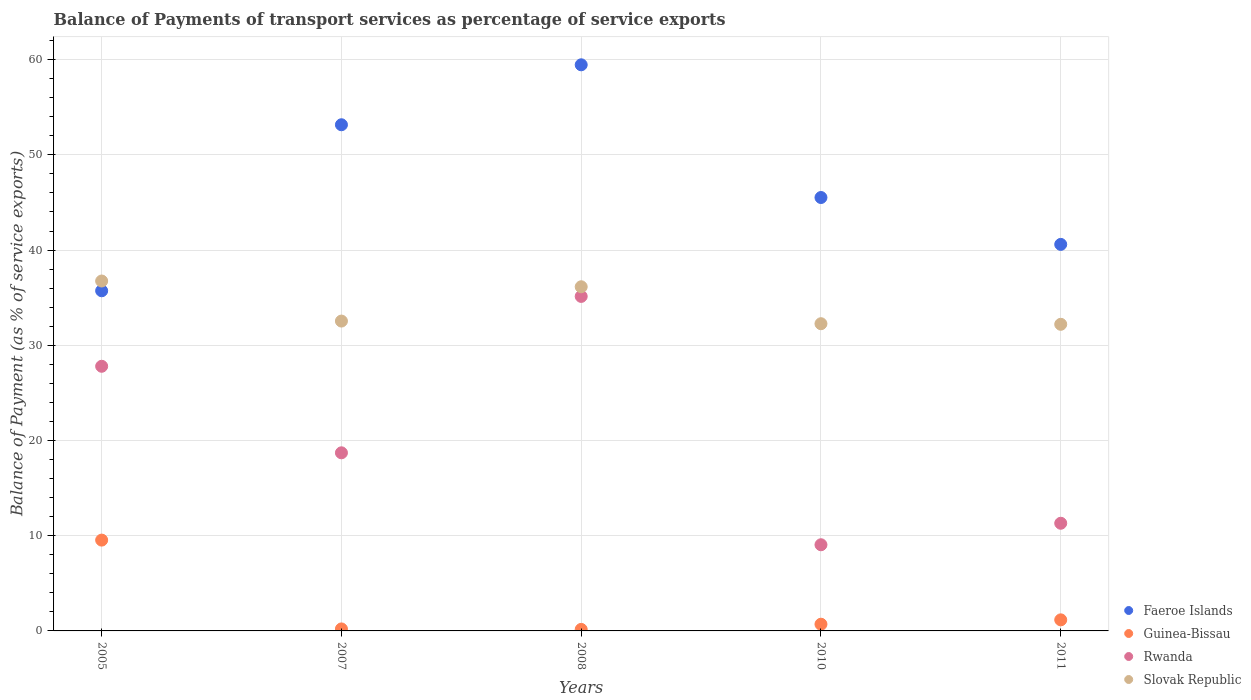Is the number of dotlines equal to the number of legend labels?
Offer a terse response. Yes. What is the balance of payments of transport services in Rwanda in 2007?
Provide a succinct answer. 18.71. Across all years, what is the maximum balance of payments of transport services in Guinea-Bissau?
Offer a terse response. 9.54. Across all years, what is the minimum balance of payments of transport services in Slovak Republic?
Give a very brief answer. 32.2. In which year was the balance of payments of transport services in Slovak Republic maximum?
Make the answer very short. 2005. What is the total balance of payments of transport services in Guinea-Bissau in the graph?
Your answer should be compact. 11.77. What is the difference between the balance of payments of transport services in Slovak Republic in 2007 and that in 2008?
Ensure brevity in your answer.  -3.6. What is the difference between the balance of payments of transport services in Rwanda in 2005 and the balance of payments of transport services in Guinea-Bissau in 2007?
Provide a short and direct response. 27.58. What is the average balance of payments of transport services in Slovak Republic per year?
Ensure brevity in your answer.  33.98. In the year 2010, what is the difference between the balance of payments of transport services in Guinea-Bissau and balance of payments of transport services in Rwanda?
Your response must be concise. -8.34. In how many years, is the balance of payments of transport services in Faeroe Islands greater than 44 %?
Keep it short and to the point. 3. What is the ratio of the balance of payments of transport services in Slovak Republic in 2007 to that in 2008?
Offer a terse response. 0.9. What is the difference between the highest and the second highest balance of payments of transport services in Slovak Republic?
Ensure brevity in your answer.  0.6. What is the difference between the highest and the lowest balance of payments of transport services in Rwanda?
Offer a very short reply. 26.08. In how many years, is the balance of payments of transport services in Rwanda greater than the average balance of payments of transport services in Rwanda taken over all years?
Keep it short and to the point. 2. Is the sum of the balance of payments of transport services in Faeroe Islands in 2010 and 2011 greater than the maximum balance of payments of transport services in Rwanda across all years?
Make the answer very short. Yes. Is it the case that in every year, the sum of the balance of payments of transport services in Guinea-Bissau and balance of payments of transport services in Slovak Republic  is greater than the sum of balance of payments of transport services in Faeroe Islands and balance of payments of transport services in Rwanda?
Give a very brief answer. No. Is it the case that in every year, the sum of the balance of payments of transport services in Slovak Republic and balance of payments of transport services in Rwanda  is greater than the balance of payments of transport services in Guinea-Bissau?
Your answer should be compact. Yes. Is the balance of payments of transport services in Rwanda strictly greater than the balance of payments of transport services in Faeroe Islands over the years?
Make the answer very short. No. How many dotlines are there?
Keep it short and to the point. 4. What is the difference between two consecutive major ticks on the Y-axis?
Provide a succinct answer. 10. Does the graph contain any zero values?
Ensure brevity in your answer.  No. Where does the legend appear in the graph?
Your answer should be compact. Bottom right. How are the legend labels stacked?
Provide a succinct answer. Vertical. What is the title of the graph?
Offer a very short reply. Balance of Payments of transport services as percentage of service exports. Does "Solomon Islands" appear as one of the legend labels in the graph?
Ensure brevity in your answer.  No. What is the label or title of the Y-axis?
Your response must be concise. Balance of Payment (as % of service exports). What is the Balance of Payment (as % of service exports) of Faeroe Islands in 2005?
Ensure brevity in your answer.  35.72. What is the Balance of Payment (as % of service exports) of Guinea-Bissau in 2005?
Your answer should be very brief. 9.54. What is the Balance of Payment (as % of service exports) of Rwanda in 2005?
Your answer should be very brief. 27.79. What is the Balance of Payment (as % of service exports) in Slovak Republic in 2005?
Offer a terse response. 36.75. What is the Balance of Payment (as % of service exports) in Faeroe Islands in 2007?
Provide a short and direct response. 53.16. What is the Balance of Payment (as % of service exports) of Guinea-Bissau in 2007?
Your answer should be compact. 0.21. What is the Balance of Payment (as % of service exports) of Rwanda in 2007?
Provide a succinct answer. 18.71. What is the Balance of Payment (as % of service exports) of Slovak Republic in 2007?
Your response must be concise. 32.54. What is the Balance of Payment (as % of service exports) of Faeroe Islands in 2008?
Your answer should be compact. 59.46. What is the Balance of Payment (as % of service exports) of Guinea-Bissau in 2008?
Your answer should be compact. 0.16. What is the Balance of Payment (as % of service exports) in Rwanda in 2008?
Your response must be concise. 35.13. What is the Balance of Payment (as % of service exports) of Slovak Republic in 2008?
Your answer should be compact. 36.14. What is the Balance of Payment (as % of service exports) of Faeroe Islands in 2010?
Make the answer very short. 45.52. What is the Balance of Payment (as % of service exports) in Guinea-Bissau in 2010?
Provide a succinct answer. 0.7. What is the Balance of Payment (as % of service exports) of Rwanda in 2010?
Provide a short and direct response. 9.05. What is the Balance of Payment (as % of service exports) in Slovak Republic in 2010?
Offer a very short reply. 32.27. What is the Balance of Payment (as % of service exports) of Faeroe Islands in 2011?
Your answer should be very brief. 40.59. What is the Balance of Payment (as % of service exports) in Guinea-Bissau in 2011?
Your answer should be compact. 1.16. What is the Balance of Payment (as % of service exports) in Rwanda in 2011?
Your answer should be very brief. 11.31. What is the Balance of Payment (as % of service exports) of Slovak Republic in 2011?
Keep it short and to the point. 32.2. Across all years, what is the maximum Balance of Payment (as % of service exports) of Faeroe Islands?
Your response must be concise. 59.46. Across all years, what is the maximum Balance of Payment (as % of service exports) in Guinea-Bissau?
Provide a succinct answer. 9.54. Across all years, what is the maximum Balance of Payment (as % of service exports) in Rwanda?
Your response must be concise. 35.13. Across all years, what is the maximum Balance of Payment (as % of service exports) in Slovak Republic?
Provide a short and direct response. 36.75. Across all years, what is the minimum Balance of Payment (as % of service exports) of Faeroe Islands?
Provide a succinct answer. 35.72. Across all years, what is the minimum Balance of Payment (as % of service exports) of Guinea-Bissau?
Provide a short and direct response. 0.16. Across all years, what is the minimum Balance of Payment (as % of service exports) in Rwanda?
Provide a short and direct response. 9.05. Across all years, what is the minimum Balance of Payment (as % of service exports) in Slovak Republic?
Make the answer very short. 32.2. What is the total Balance of Payment (as % of service exports) of Faeroe Islands in the graph?
Give a very brief answer. 234.45. What is the total Balance of Payment (as % of service exports) in Guinea-Bissau in the graph?
Make the answer very short. 11.77. What is the total Balance of Payment (as % of service exports) in Rwanda in the graph?
Your answer should be very brief. 101.99. What is the total Balance of Payment (as % of service exports) of Slovak Republic in the graph?
Ensure brevity in your answer.  169.9. What is the difference between the Balance of Payment (as % of service exports) in Faeroe Islands in 2005 and that in 2007?
Your answer should be compact. -17.44. What is the difference between the Balance of Payment (as % of service exports) of Guinea-Bissau in 2005 and that in 2007?
Offer a very short reply. 9.33. What is the difference between the Balance of Payment (as % of service exports) of Rwanda in 2005 and that in 2007?
Keep it short and to the point. 9.09. What is the difference between the Balance of Payment (as % of service exports) of Slovak Republic in 2005 and that in 2007?
Provide a short and direct response. 4.21. What is the difference between the Balance of Payment (as % of service exports) of Faeroe Islands in 2005 and that in 2008?
Provide a short and direct response. -23.73. What is the difference between the Balance of Payment (as % of service exports) of Guinea-Bissau in 2005 and that in 2008?
Keep it short and to the point. 9.38. What is the difference between the Balance of Payment (as % of service exports) in Rwanda in 2005 and that in 2008?
Make the answer very short. -7.34. What is the difference between the Balance of Payment (as % of service exports) in Slovak Republic in 2005 and that in 2008?
Provide a succinct answer. 0.6. What is the difference between the Balance of Payment (as % of service exports) of Faeroe Islands in 2005 and that in 2010?
Your answer should be compact. -9.8. What is the difference between the Balance of Payment (as % of service exports) in Guinea-Bissau in 2005 and that in 2010?
Give a very brief answer. 8.83. What is the difference between the Balance of Payment (as % of service exports) in Rwanda in 2005 and that in 2010?
Provide a short and direct response. 18.74. What is the difference between the Balance of Payment (as % of service exports) in Slovak Republic in 2005 and that in 2010?
Your answer should be very brief. 4.48. What is the difference between the Balance of Payment (as % of service exports) of Faeroe Islands in 2005 and that in 2011?
Make the answer very short. -4.87. What is the difference between the Balance of Payment (as % of service exports) of Guinea-Bissau in 2005 and that in 2011?
Provide a short and direct response. 8.37. What is the difference between the Balance of Payment (as % of service exports) of Rwanda in 2005 and that in 2011?
Provide a succinct answer. 16.49. What is the difference between the Balance of Payment (as % of service exports) in Slovak Republic in 2005 and that in 2011?
Offer a terse response. 4.55. What is the difference between the Balance of Payment (as % of service exports) in Faeroe Islands in 2007 and that in 2008?
Offer a terse response. -6.3. What is the difference between the Balance of Payment (as % of service exports) of Guinea-Bissau in 2007 and that in 2008?
Provide a succinct answer. 0.05. What is the difference between the Balance of Payment (as % of service exports) of Rwanda in 2007 and that in 2008?
Provide a short and direct response. -16.43. What is the difference between the Balance of Payment (as % of service exports) in Slovak Republic in 2007 and that in 2008?
Your answer should be very brief. -3.6. What is the difference between the Balance of Payment (as % of service exports) in Faeroe Islands in 2007 and that in 2010?
Make the answer very short. 7.64. What is the difference between the Balance of Payment (as % of service exports) in Guinea-Bissau in 2007 and that in 2010?
Provide a short and direct response. -0.5. What is the difference between the Balance of Payment (as % of service exports) of Rwanda in 2007 and that in 2010?
Ensure brevity in your answer.  9.66. What is the difference between the Balance of Payment (as % of service exports) of Slovak Republic in 2007 and that in 2010?
Give a very brief answer. 0.28. What is the difference between the Balance of Payment (as % of service exports) in Faeroe Islands in 2007 and that in 2011?
Your response must be concise. 12.57. What is the difference between the Balance of Payment (as % of service exports) in Guinea-Bissau in 2007 and that in 2011?
Offer a terse response. -0.95. What is the difference between the Balance of Payment (as % of service exports) of Rwanda in 2007 and that in 2011?
Make the answer very short. 7.4. What is the difference between the Balance of Payment (as % of service exports) of Slovak Republic in 2007 and that in 2011?
Make the answer very short. 0.34. What is the difference between the Balance of Payment (as % of service exports) in Faeroe Islands in 2008 and that in 2010?
Provide a succinct answer. 13.94. What is the difference between the Balance of Payment (as % of service exports) in Guinea-Bissau in 2008 and that in 2010?
Give a very brief answer. -0.54. What is the difference between the Balance of Payment (as % of service exports) of Rwanda in 2008 and that in 2010?
Your answer should be compact. 26.08. What is the difference between the Balance of Payment (as % of service exports) of Slovak Republic in 2008 and that in 2010?
Make the answer very short. 3.88. What is the difference between the Balance of Payment (as % of service exports) in Faeroe Islands in 2008 and that in 2011?
Offer a terse response. 18.86. What is the difference between the Balance of Payment (as % of service exports) in Guinea-Bissau in 2008 and that in 2011?
Make the answer very short. -1. What is the difference between the Balance of Payment (as % of service exports) in Rwanda in 2008 and that in 2011?
Make the answer very short. 23.82. What is the difference between the Balance of Payment (as % of service exports) of Slovak Republic in 2008 and that in 2011?
Give a very brief answer. 3.94. What is the difference between the Balance of Payment (as % of service exports) of Faeroe Islands in 2010 and that in 2011?
Make the answer very short. 4.92. What is the difference between the Balance of Payment (as % of service exports) of Guinea-Bissau in 2010 and that in 2011?
Give a very brief answer. -0.46. What is the difference between the Balance of Payment (as % of service exports) of Rwanda in 2010 and that in 2011?
Offer a terse response. -2.26. What is the difference between the Balance of Payment (as % of service exports) of Slovak Republic in 2010 and that in 2011?
Provide a succinct answer. 0.06. What is the difference between the Balance of Payment (as % of service exports) of Faeroe Islands in 2005 and the Balance of Payment (as % of service exports) of Guinea-Bissau in 2007?
Keep it short and to the point. 35.51. What is the difference between the Balance of Payment (as % of service exports) of Faeroe Islands in 2005 and the Balance of Payment (as % of service exports) of Rwanda in 2007?
Make the answer very short. 17.02. What is the difference between the Balance of Payment (as % of service exports) in Faeroe Islands in 2005 and the Balance of Payment (as % of service exports) in Slovak Republic in 2007?
Make the answer very short. 3.18. What is the difference between the Balance of Payment (as % of service exports) in Guinea-Bissau in 2005 and the Balance of Payment (as % of service exports) in Rwanda in 2007?
Provide a succinct answer. -9.17. What is the difference between the Balance of Payment (as % of service exports) in Guinea-Bissau in 2005 and the Balance of Payment (as % of service exports) in Slovak Republic in 2007?
Provide a succinct answer. -23. What is the difference between the Balance of Payment (as % of service exports) in Rwanda in 2005 and the Balance of Payment (as % of service exports) in Slovak Republic in 2007?
Provide a succinct answer. -4.75. What is the difference between the Balance of Payment (as % of service exports) in Faeroe Islands in 2005 and the Balance of Payment (as % of service exports) in Guinea-Bissau in 2008?
Give a very brief answer. 35.56. What is the difference between the Balance of Payment (as % of service exports) of Faeroe Islands in 2005 and the Balance of Payment (as % of service exports) of Rwanda in 2008?
Your response must be concise. 0.59. What is the difference between the Balance of Payment (as % of service exports) of Faeroe Islands in 2005 and the Balance of Payment (as % of service exports) of Slovak Republic in 2008?
Provide a short and direct response. -0.42. What is the difference between the Balance of Payment (as % of service exports) of Guinea-Bissau in 2005 and the Balance of Payment (as % of service exports) of Rwanda in 2008?
Provide a short and direct response. -25.59. What is the difference between the Balance of Payment (as % of service exports) of Guinea-Bissau in 2005 and the Balance of Payment (as % of service exports) of Slovak Republic in 2008?
Your response must be concise. -26.61. What is the difference between the Balance of Payment (as % of service exports) in Rwanda in 2005 and the Balance of Payment (as % of service exports) in Slovak Republic in 2008?
Keep it short and to the point. -8.35. What is the difference between the Balance of Payment (as % of service exports) of Faeroe Islands in 2005 and the Balance of Payment (as % of service exports) of Guinea-Bissau in 2010?
Provide a short and direct response. 35.02. What is the difference between the Balance of Payment (as % of service exports) in Faeroe Islands in 2005 and the Balance of Payment (as % of service exports) in Rwanda in 2010?
Offer a terse response. 26.67. What is the difference between the Balance of Payment (as % of service exports) of Faeroe Islands in 2005 and the Balance of Payment (as % of service exports) of Slovak Republic in 2010?
Your response must be concise. 3.46. What is the difference between the Balance of Payment (as % of service exports) in Guinea-Bissau in 2005 and the Balance of Payment (as % of service exports) in Rwanda in 2010?
Your answer should be compact. 0.49. What is the difference between the Balance of Payment (as % of service exports) in Guinea-Bissau in 2005 and the Balance of Payment (as % of service exports) in Slovak Republic in 2010?
Provide a short and direct response. -22.73. What is the difference between the Balance of Payment (as % of service exports) in Rwanda in 2005 and the Balance of Payment (as % of service exports) in Slovak Republic in 2010?
Provide a succinct answer. -4.47. What is the difference between the Balance of Payment (as % of service exports) in Faeroe Islands in 2005 and the Balance of Payment (as % of service exports) in Guinea-Bissau in 2011?
Ensure brevity in your answer.  34.56. What is the difference between the Balance of Payment (as % of service exports) in Faeroe Islands in 2005 and the Balance of Payment (as % of service exports) in Rwanda in 2011?
Make the answer very short. 24.42. What is the difference between the Balance of Payment (as % of service exports) of Faeroe Islands in 2005 and the Balance of Payment (as % of service exports) of Slovak Republic in 2011?
Your answer should be compact. 3.52. What is the difference between the Balance of Payment (as % of service exports) of Guinea-Bissau in 2005 and the Balance of Payment (as % of service exports) of Rwanda in 2011?
Your response must be concise. -1.77. What is the difference between the Balance of Payment (as % of service exports) in Guinea-Bissau in 2005 and the Balance of Payment (as % of service exports) in Slovak Republic in 2011?
Offer a terse response. -22.67. What is the difference between the Balance of Payment (as % of service exports) of Rwanda in 2005 and the Balance of Payment (as % of service exports) of Slovak Republic in 2011?
Give a very brief answer. -4.41. What is the difference between the Balance of Payment (as % of service exports) in Faeroe Islands in 2007 and the Balance of Payment (as % of service exports) in Guinea-Bissau in 2008?
Keep it short and to the point. 53. What is the difference between the Balance of Payment (as % of service exports) of Faeroe Islands in 2007 and the Balance of Payment (as % of service exports) of Rwanda in 2008?
Your answer should be compact. 18.03. What is the difference between the Balance of Payment (as % of service exports) of Faeroe Islands in 2007 and the Balance of Payment (as % of service exports) of Slovak Republic in 2008?
Provide a succinct answer. 17.02. What is the difference between the Balance of Payment (as % of service exports) in Guinea-Bissau in 2007 and the Balance of Payment (as % of service exports) in Rwanda in 2008?
Provide a succinct answer. -34.92. What is the difference between the Balance of Payment (as % of service exports) of Guinea-Bissau in 2007 and the Balance of Payment (as % of service exports) of Slovak Republic in 2008?
Ensure brevity in your answer.  -35.94. What is the difference between the Balance of Payment (as % of service exports) in Rwanda in 2007 and the Balance of Payment (as % of service exports) in Slovak Republic in 2008?
Keep it short and to the point. -17.44. What is the difference between the Balance of Payment (as % of service exports) in Faeroe Islands in 2007 and the Balance of Payment (as % of service exports) in Guinea-Bissau in 2010?
Ensure brevity in your answer.  52.46. What is the difference between the Balance of Payment (as % of service exports) of Faeroe Islands in 2007 and the Balance of Payment (as % of service exports) of Rwanda in 2010?
Give a very brief answer. 44.11. What is the difference between the Balance of Payment (as % of service exports) of Faeroe Islands in 2007 and the Balance of Payment (as % of service exports) of Slovak Republic in 2010?
Make the answer very short. 20.89. What is the difference between the Balance of Payment (as % of service exports) in Guinea-Bissau in 2007 and the Balance of Payment (as % of service exports) in Rwanda in 2010?
Provide a succinct answer. -8.84. What is the difference between the Balance of Payment (as % of service exports) of Guinea-Bissau in 2007 and the Balance of Payment (as % of service exports) of Slovak Republic in 2010?
Your answer should be compact. -32.06. What is the difference between the Balance of Payment (as % of service exports) in Rwanda in 2007 and the Balance of Payment (as % of service exports) in Slovak Republic in 2010?
Provide a succinct answer. -13.56. What is the difference between the Balance of Payment (as % of service exports) in Faeroe Islands in 2007 and the Balance of Payment (as % of service exports) in Guinea-Bissau in 2011?
Provide a short and direct response. 52. What is the difference between the Balance of Payment (as % of service exports) in Faeroe Islands in 2007 and the Balance of Payment (as % of service exports) in Rwanda in 2011?
Provide a succinct answer. 41.85. What is the difference between the Balance of Payment (as % of service exports) in Faeroe Islands in 2007 and the Balance of Payment (as % of service exports) in Slovak Republic in 2011?
Provide a short and direct response. 20.96. What is the difference between the Balance of Payment (as % of service exports) of Guinea-Bissau in 2007 and the Balance of Payment (as % of service exports) of Rwanda in 2011?
Your response must be concise. -11.1. What is the difference between the Balance of Payment (as % of service exports) of Guinea-Bissau in 2007 and the Balance of Payment (as % of service exports) of Slovak Republic in 2011?
Your answer should be very brief. -31.99. What is the difference between the Balance of Payment (as % of service exports) of Rwanda in 2007 and the Balance of Payment (as % of service exports) of Slovak Republic in 2011?
Keep it short and to the point. -13.5. What is the difference between the Balance of Payment (as % of service exports) of Faeroe Islands in 2008 and the Balance of Payment (as % of service exports) of Guinea-Bissau in 2010?
Offer a very short reply. 58.75. What is the difference between the Balance of Payment (as % of service exports) of Faeroe Islands in 2008 and the Balance of Payment (as % of service exports) of Rwanda in 2010?
Offer a very short reply. 50.41. What is the difference between the Balance of Payment (as % of service exports) in Faeroe Islands in 2008 and the Balance of Payment (as % of service exports) in Slovak Republic in 2010?
Provide a succinct answer. 27.19. What is the difference between the Balance of Payment (as % of service exports) in Guinea-Bissau in 2008 and the Balance of Payment (as % of service exports) in Rwanda in 2010?
Give a very brief answer. -8.89. What is the difference between the Balance of Payment (as % of service exports) of Guinea-Bissau in 2008 and the Balance of Payment (as % of service exports) of Slovak Republic in 2010?
Ensure brevity in your answer.  -32.11. What is the difference between the Balance of Payment (as % of service exports) of Rwanda in 2008 and the Balance of Payment (as % of service exports) of Slovak Republic in 2010?
Offer a terse response. 2.87. What is the difference between the Balance of Payment (as % of service exports) of Faeroe Islands in 2008 and the Balance of Payment (as % of service exports) of Guinea-Bissau in 2011?
Provide a succinct answer. 58.29. What is the difference between the Balance of Payment (as % of service exports) in Faeroe Islands in 2008 and the Balance of Payment (as % of service exports) in Rwanda in 2011?
Your answer should be very brief. 48.15. What is the difference between the Balance of Payment (as % of service exports) of Faeroe Islands in 2008 and the Balance of Payment (as % of service exports) of Slovak Republic in 2011?
Offer a very short reply. 27.25. What is the difference between the Balance of Payment (as % of service exports) in Guinea-Bissau in 2008 and the Balance of Payment (as % of service exports) in Rwanda in 2011?
Give a very brief answer. -11.15. What is the difference between the Balance of Payment (as % of service exports) of Guinea-Bissau in 2008 and the Balance of Payment (as % of service exports) of Slovak Republic in 2011?
Your answer should be very brief. -32.04. What is the difference between the Balance of Payment (as % of service exports) in Rwanda in 2008 and the Balance of Payment (as % of service exports) in Slovak Republic in 2011?
Provide a succinct answer. 2.93. What is the difference between the Balance of Payment (as % of service exports) in Faeroe Islands in 2010 and the Balance of Payment (as % of service exports) in Guinea-Bissau in 2011?
Provide a short and direct response. 44.36. What is the difference between the Balance of Payment (as % of service exports) in Faeroe Islands in 2010 and the Balance of Payment (as % of service exports) in Rwanda in 2011?
Offer a very short reply. 34.21. What is the difference between the Balance of Payment (as % of service exports) of Faeroe Islands in 2010 and the Balance of Payment (as % of service exports) of Slovak Republic in 2011?
Provide a short and direct response. 13.32. What is the difference between the Balance of Payment (as % of service exports) in Guinea-Bissau in 2010 and the Balance of Payment (as % of service exports) in Rwanda in 2011?
Your answer should be very brief. -10.6. What is the difference between the Balance of Payment (as % of service exports) of Guinea-Bissau in 2010 and the Balance of Payment (as % of service exports) of Slovak Republic in 2011?
Provide a short and direct response. -31.5. What is the difference between the Balance of Payment (as % of service exports) in Rwanda in 2010 and the Balance of Payment (as % of service exports) in Slovak Republic in 2011?
Your response must be concise. -23.15. What is the average Balance of Payment (as % of service exports) of Faeroe Islands per year?
Make the answer very short. 46.89. What is the average Balance of Payment (as % of service exports) of Guinea-Bissau per year?
Provide a short and direct response. 2.35. What is the average Balance of Payment (as % of service exports) in Rwanda per year?
Make the answer very short. 20.4. What is the average Balance of Payment (as % of service exports) of Slovak Republic per year?
Your answer should be compact. 33.98. In the year 2005, what is the difference between the Balance of Payment (as % of service exports) in Faeroe Islands and Balance of Payment (as % of service exports) in Guinea-Bissau?
Offer a terse response. 26.19. In the year 2005, what is the difference between the Balance of Payment (as % of service exports) of Faeroe Islands and Balance of Payment (as % of service exports) of Rwanda?
Ensure brevity in your answer.  7.93. In the year 2005, what is the difference between the Balance of Payment (as % of service exports) of Faeroe Islands and Balance of Payment (as % of service exports) of Slovak Republic?
Keep it short and to the point. -1.03. In the year 2005, what is the difference between the Balance of Payment (as % of service exports) of Guinea-Bissau and Balance of Payment (as % of service exports) of Rwanda?
Your answer should be very brief. -18.26. In the year 2005, what is the difference between the Balance of Payment (as % of service exports) in Guinea-Bissau and Balance of Payment (as % of service exports) in Slovak Republic?
Keep it short and to the point. -27.21. In the year 2005, what is the difference between the Balance of Payment (as % of service exports) in Rwanda and Balance of Payment (as % of service exports) in Slovak Republic?
Make the answer very short. -8.96. In the year 2007, what is the difference between the Balance of Payment (as % of service exports) of Faeroe Islands and Balance of Payment (as % of service exports) of Guinea-Bissau?
Your response must be concise. 52.95. In the year 2007, what is the difference between the Balance of Payment (as % of service exports) of Faeroe Islands and Balance of Payment (as % of service exports) of Rwanda?
Your answer should be compact. 34.45. In the year 2007, what is the difference between the Balance of Payment (as % of service exports) of Faeroe Islands and Balance of Payment (as % of service exports) of Slovak Republic?
Keep it short and to the point. 20.62. In the year 2007, what is the difference between the Balance of Payment (as % of service exports) in Guinea-Bissau and Balance of Payment (as % of service exports) in Rwanda?
Your answer should be very brief. -18.5. In the year 2007, what is the difference between the Balance of Payment (as % of service exports) of Guinea-Bissau and Balance of Payment (as % of service exports) of Slovak Republic?
Offer a very short reply. -32.33. In the year 2007, what is the difference between the Balance of Payment (as % of service exports) in Rwanda and Balance of Payment (as % of service exports) in Slovak Republic?
Provide a short and direct response. -13.84. In the year 2008, what is the difference between the Balance of Payment (as % of service exports) in Faeroe Islands and Balance of Payment (as % of service exports) in Guinea-Bissau?
Your response must be concise. 59.3. In the year 2008, what is the difference between the Balance of Payment (as % of service exports) in Faeroe Islands and Balance of Payment (as % of service exports) in Rwanda?
Your answer should be very brief. 24.32. In the year 2008, what is the difference between the Balance of Payment (as % of service exports) in Faeroe Islands and Balance of Payment (as % of service exports) in Slovak Republic?
Offer a terse response. 23.31. In the year 2008, what is the difference between the Balance of Payment (as % of service exports) of Guinea-Bissau and Balance of Payment (as % of service exports) of Rwanda?
Your answer should be compact. -34.97. In the year 2008, what is the difference between the Balance of Payment (as % of service exports) of Guinea-Bissau and Balance of Payment (as % of service exports) of Slovak Republic?
Provide a succinct answer. -35.98. In the year 2008, what is the difference between the Balance of Payment (as % of service exports) of Rwanda and Balance of Payment (as % of service exports) of Slovak Republic?
Give a very brief answer. -1.01. In the year 2010, what is the difference between the Balance of Payment (as % of service exports) of Faeroe Islands and Balance of Payment (as % of service exports) of Guinea-Bissau?
Provide a short and direct response. 44.81. In the year 2010, what is the difference between the Balance of Payment (as % of service exports) of Faeroe Islands and Balance of Payment (as % of service exports) of Rwanda?
Ensure brevity in your answer.  36.47. In the year 2010, what is the difference between the Balance of Payment (as % of service exports) in Faeroe Islands and Balance of Payment (as % of service exports) in Slovak Republic?
Your response must be concise. 13.25. In the year 2010, what is the difference between the Balance of Payment (as % of service exports) in Guinea-Bissau and Balance of Payment (as % of service exports) in Rwanda?
Your response must be concise. -8.34. In the year 2010, what is the difference between the Balance of Payment (as % of service exports) of Guinea-Bissau and Balance of Payment (as % of service exports) of Slovak Republic?
Your answer should be very brief. -31.56. In the year 2010, what is the difference between the Balance of Payment (as % of service exports) in Rwanda and Balance of Payment (as % of service exports) in Slovak Republic?
Provide a short and direct response. -23.22. In the year 2011, what is the difference between the Balance of Payment (as % of service exports) in Faeroe Islands and Balance of Payment (as % of service exports) in Guinea-Bissau?
Your answer should be very brief. 39.43. In the year 2011, what is the difference between the Balance of Payment (as % of service exports) of Faeroe Islands and Balance of Payment (as % of service exports) of Rwanda?
Your answer should be compact. 29.29. In the year 2011, what is the difference between the Balance of Payment (as % of service exports) in Faeroe Islands and Balance of Payment (as % of service exports) in Slovak Republic?
Provide a succinct answer. 8.39. In the year 2011, what is the difference between the Balance of Payment (as % of service exports) of Guinea-Bissau and Balance of Payment (as % of service exports) of Rwanda?
Offer a very short reply. -10.14. In the year 2011, what is the difference between the Balance of Payment (as % of service exports) in Guinea-Bissau and Balance of Payment (as % of service exports) in Slovak Republic?
Your response must be concise. -31.04. In the year 2011, what is the difference between the Balance of Payment (as % of service exports) in Rwanda and Balance of Payment (as % of service exports) in Slovak Republic?
Give a very brief answer. -20.9. What is the ratio of the Balance of Payment (as % of service exports) in Faeroe Islands in 2005 to that in 2007?
Your answer should be compact. 0.67. What is the ratio of the Balance of Payment (as % of service exports) in Guinea-Bissau in 2005 to that in 2007?
Your response must be concise. 45.5. What is the ratio of the Balance of Payment (as % of service exports) in Rwanda in 2005 to that in 2007?
Your answer should be very brief. 1.49. What is the ratio of the Balance of Payment (as % of service exports) in Slovak Republic in 2005 to that in 2007?
Your answer should be very brief. 1.13. What is the ratio of the Balance of Payment (as % of service exports) of Faeroe Islands in 2005 to that in 2008?
Ensure brevity in your answer.  0.6. What is the ratio of the Balance of Payment (as % of service exports) of Guinea-Bissau in 2005 to that in 2008?
Make the answer very short. 59.64. What is the ratio of the Balance of Payment (as % of service exports) in Rwanda in 2005 to that in 2008?
Ensure brevity in your answer.  0.79. What is the ratio of the Balance of Payment (as % of service exports) of Slovak Republic in 2005 to that in 2008?
Make the answer very short. 1.02. What is the ratio of the Balance of Payment (as % of service exports) in Faeroe Islands in 2005 to that in 2010?
Ensure brevity in your answer.  0.78. What is the ratio of the Balance of Payment (as % of service exports) in Guinea-Bissau in 2005 to that in 2010?
Keep it short and to the point. 13.53. What is the ratio of the Balance of Payment (as % of service exports) of Rwanda in 2005 to that in 2010?
Offer a terse response. 3.07. What is the ratio of the Balance of Payment (as % of service exports) in Slovak Republic in 2005 to that in 2010?
Offer a very short reply. 1.14. What is the ratio of the Balance of Payment (as % of service exports) of Guinea-Bissau in 2005 to that in 2011?
Your answer should be compact. 8.2. What is the ratio of the Balance of Payment (as % of service exports) in Rwanda in 2005 to that in 2011?
Your answer should be very brief. 2.46. What is the ratio of the Balance of Payment (as % of service exports) of Slovak Republic in 2005 to that in 2011?
Give a very brief answer. 1.14. What is the ratio of the Balance of Payment (as % of service exports) in Faeroe Islands in 2007 to that in 2008?
Make the answer very short. 0.89. What is the ratio of the Balance of Payment (as % of service exports) of Guinea-Bissau in 2007 to that in 2008?
Your answer should be compact. 1.31. What is the ratio of the Balance of Payment (as % of service exports) in Rwanda in 2007 to that in 2008?
Provide a succinct answer. 0.53. What is the ratio of the Balance of Payment (as % of service exports) in Slovak Republic in 2007 to that in 2008?
Make the answer very short. 0.9. What is the ratio of the Balance of Payment (as % of service exports) of Faeroe Islands in 2007 to that in 2010?
Your response must be concise. 1.17. What is the ratio of the Balance of Payment (as % of service exports) of Guinea-Bissau in 2007 to that in 2010?
Make the answer very short. 0.3. What is the ratio of the Balance of Payment (as % of service exports) in Rwanda in 2007 to that in 2010?
Your answer should be compact. 2.07. What is the ratio of the Balance of Payment (as % of service exports) of Slovak Republic in 2007 to that in 2010?
Provide a short and direct response. 1.01. What is the ratio of the Balance of Payment (as % of service exports) of Faeroe Islands in 2007 to that in 2011?
Keep it short and to the point. 1.31. What is the ratio of the Balance of Payment (as % of service exports) in Guinea-Bissau in 2007 to that in 2011?
Keep it short and to the point. 0.18. What is the ratio of the Balance of Payment (as % of service exports) of Rwanda in 2007 to that in 2011?
Your answer should be very brief. 1.65. What is the ratio of the Balance of Payment (as % of service exports) in Slovak Republic in 2007 to that in 2011?
Your answer should be compact. 1.01. What is the ratio of the Balance of Payment (as % of service exports) in Faeroe Islands in 2008 to that in 2010?
Give a very brief answer. 1.31. What is the ratio of the Balance of Payment (as % of service exports) in Guinea-Bissau in 2008 to that in 2010?
Offer a very short reply. 0.23. What is the ratio of the Balance of Payment (as % of service exports) of Rwanda in 2008 to that in 2010?
Provide a short and direct response. 3.88. What is the ratio of the Balance of Payment (as % of service exports) in Slovak Republic in 2008 to that in 2010?
Your answer should be compact. 1.12. What is the ratio of the Balance of Payment (as % of service exports) of Faeroe Islands in 2008 to that in 2011?
Offer a very short reply. 1.46. What is the ratio of the Balance of Payment (as % of service exports) of Guinea-Bissau in 2008 to that in 2011?
Offer a terse response. 0.14. What is the ratio of the Balance of Payment (as % of service exports) in Rwanda in 2008 to that in 2011?
Offer a terse response. 3.11. What is the ratio of the Balance of Payment (as % of service exports) in Slovak Republic in 2008 to that in 2011?
Ensure brevity in your answer.  1.12. What is the ratio of the Balance of Payment (as % of service exports) in Faeroe Islands in 2010 to that in 2011?
Offer a very short reply. 1.12. What is the ratio of the Balance of Payment (as % of service exports) in Guinea-Bissau in 2010 to that in 2011?
Make the answer very short. 0.61. What is the ratio of the Balance of Payment (as % of service exports) in Rwanda in 2010 to that in 2011?
Offer a terse response. 0.8. What is the ratio of the Balance of Payment (as % of service exports) in Slovak Republic in 2010 to that in 2011?
Offer a very short reply. 1. What is the difference between the highest and the second highest Balance of Payment (as % of service exports) of Faeroe Islands?
Keep it short and to the point. 6.3. What is the difference between the highest and the second highest Balance of Payment (as % of service exports) of Guinea-Bissau?
Your answer should be compact. 8.37. What is the difference between the highest and the second highest Balance of Payment (as % of service exports) of Rwanda?
Offer a very short reply. 7.34. What is the difference between the highest and the second highest Balance of Payment (as % of service exports) in Slovak Republic?
Your answer should be very brief. 0.6. What is the difference between the highest and the lowest Balance of Payment (as % of service exports) of Faeroe Islands?
Make the answer very short. 23.73. What is the difference between the highest and the lowest Balance of Payment (as % of service exports) of Guinea-Bissau?
Make the answer very short. 9.38. What is the difference between the highest and the lowest Balance of Payment (as % of service exports) of Rwanda?
Your answer should be very brief. 26.08. What is the difference between the highest and the lowest Balance of Payment (as % of service exports) of Slovak Republic?
Ensure brevity in your answer.  4.55. 